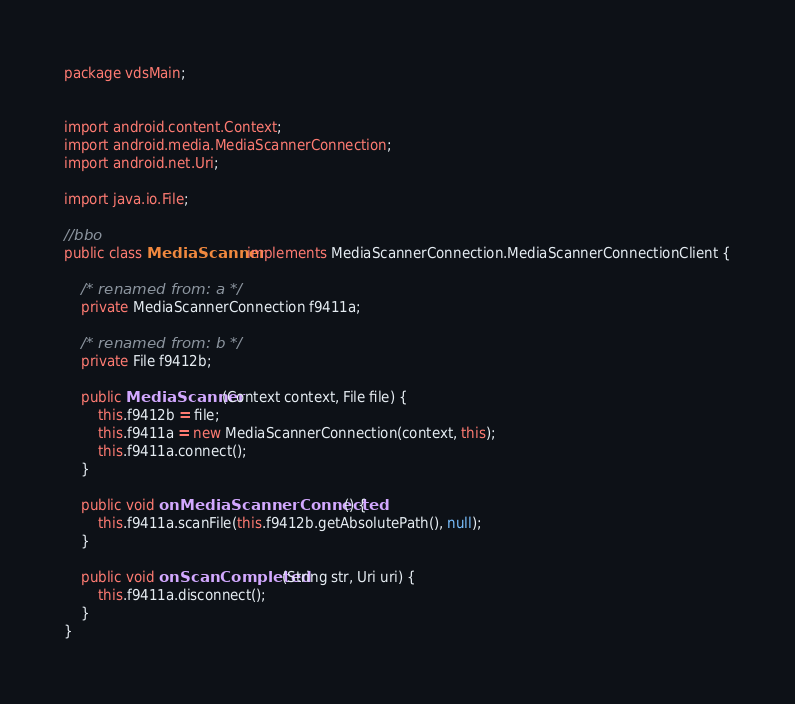<code> <loc_0><loc_0><loc_500><loc_500><_Java_>package vdsMain;


import android.content.Context;
import android.media.MediaScannerConnection;
import android.net.Uri;

import java.io.File;

//bbo
public class MediaScanner implements MediaScannerConnection.MediaScannerConnectionClient {

    /* renamed from: a */
    private MediaScannerConnection f9411a;

    /* renamed from: b */
    private File f9412b;

    public MediaScanner(Context context, File file) {
        this.f9412b = file;
        this.f9411a = new MediaScannerConnection(context, this);
        this.f9411a.connect();
    }

    public void onMediaScannerConnected() {
        this.f9411a.scanFile(this.f9412b.getAbsolutePath(), null);
    }

    public void onScanCompleted(String str, Uri uri) {
        this.f9411a.disconnect();
    }
}
</code> 